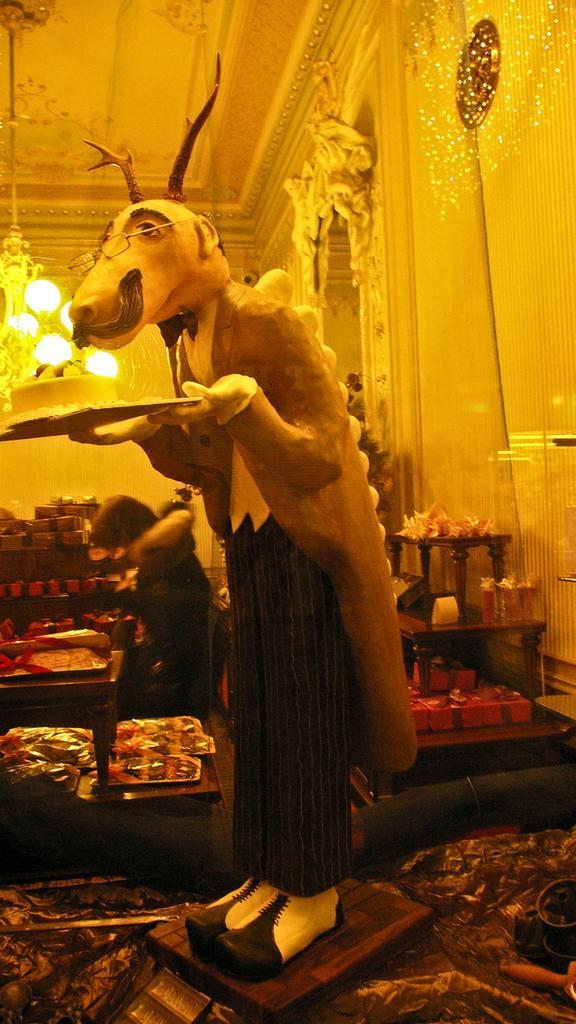In one or two sentences, can you explain what this image depicts? In this picture we can see a statue, trays, gift boxes, chandelier, lights, wall and a person standing and some objects. 